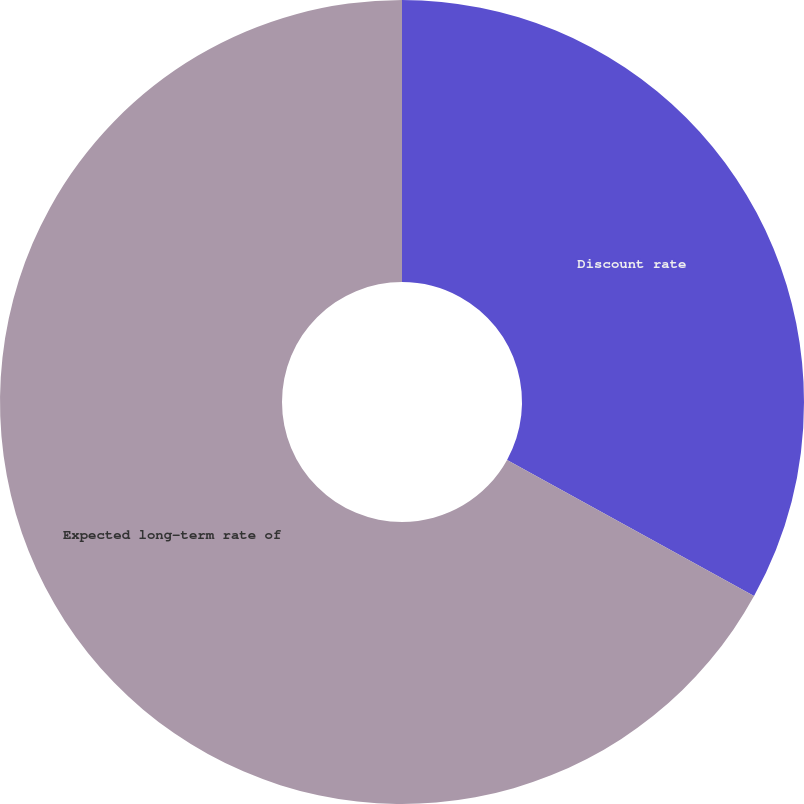<chart> <loc_0><loc_0><loc_500><loc_500><pie_chart><fcel>Discount rate<fcel>Expected long-term rate of<nl><fcel>33.02%<fcel>66.98%<nl></chart> 